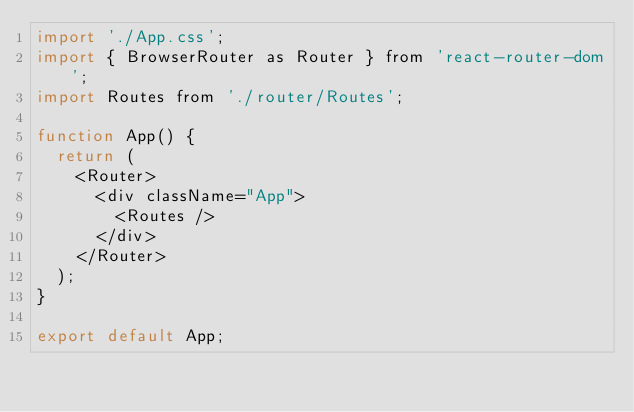Convert code to text. <code><loc_0><loc_0><loc_500><loc_500><_JavaScript_>import './App.css';
import { BrowserRouter as Router } from 'react-router-dom';
import Routes from './router/Routes';

function App() {
  return (
    <Router>
      <div className="App">
        <Routes />
      </div>
    </Router>
  );
}

export default App;
</code> 